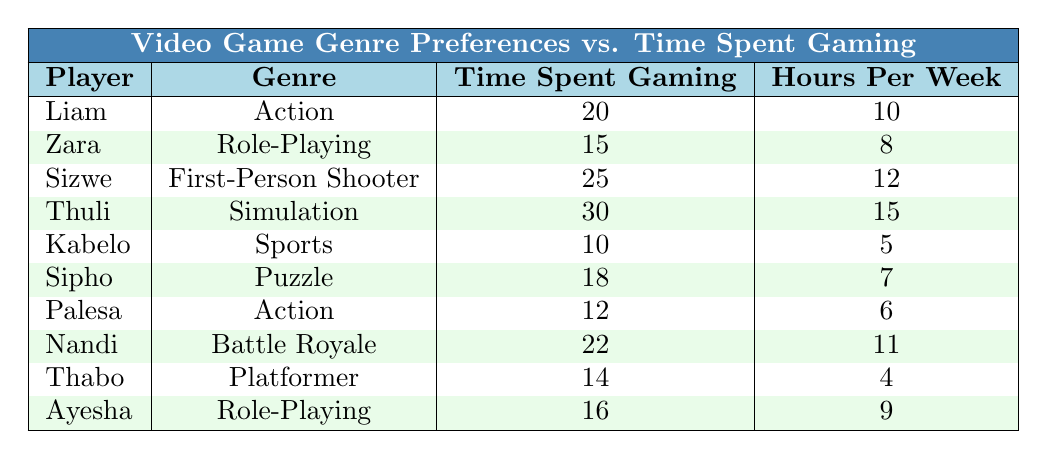What is the genre played by Sizwe? In the table, we look for Sizwe's row to find the genre he plays. The table indicates that Sizwe's genre is First-Person Shooter.
Answer: First-Person Shooter Who spent the most time gaming? By inspecting the "Time Spent Gaming" column, we see that Thuli has the highest value at 30 hours.
Answer: Thuli What is the average time spent gaming by players who enjoy Role-Playing games? We find the players who play Role-Playing: Zara (15 hours) and Ayesha (16 hours). Adding these values gives us 15 + 16 = 31. To find the average, we divide by the number of players (2), which is 31/2 = 15.5.
Answer: 15.5 Is there anyone who spends 10 hours or less gaming? Checking the "Time Spent Gaming" column, we see Kabelo who spent 10 hours gaming, thus the statement is true.
Answer: Yes What is the difference between the time spent gaming by the player who spends the least time and the player who spends the most time? The minimum time spent comes from Kabelo with 10 hours and the maximum is Thuli with 30 hours. The difference is calculated by subtracting: 30 - 10 = 20 hours.
Answer: 20 What fraction of players play Action games? The players who play Action are Liam and Palesa, totaling 2 players. There are 10 players in total, making the fraction 2/10, which simplifies to 1/5.
Answer: 1/5 How many players spend more than 15 hours gaming? We examine the "Time Spent Gaming" column and count the players: Sizwe (25), Thuli (30), Nandi (22), and Sipho (18). This gives us 4 players spending more than 15 hours.
Answer: 4 Are there more players playing Simulation games than Sports games? The table shows only Thuli plays Simulation and only Kabelo plays Sports. Since both have 1 player each, the answer tends to be no.
Answer: No What is the total time spent gaming by the players who prefer Puzzle and Sports genres? We look at Sipho (Puzzle) who spent 18 hours and Kabelo (Sports) who spent 10 hours. Adding these gives us 18 + 10 = 28 hours for both genres combined.
Answer: 28 